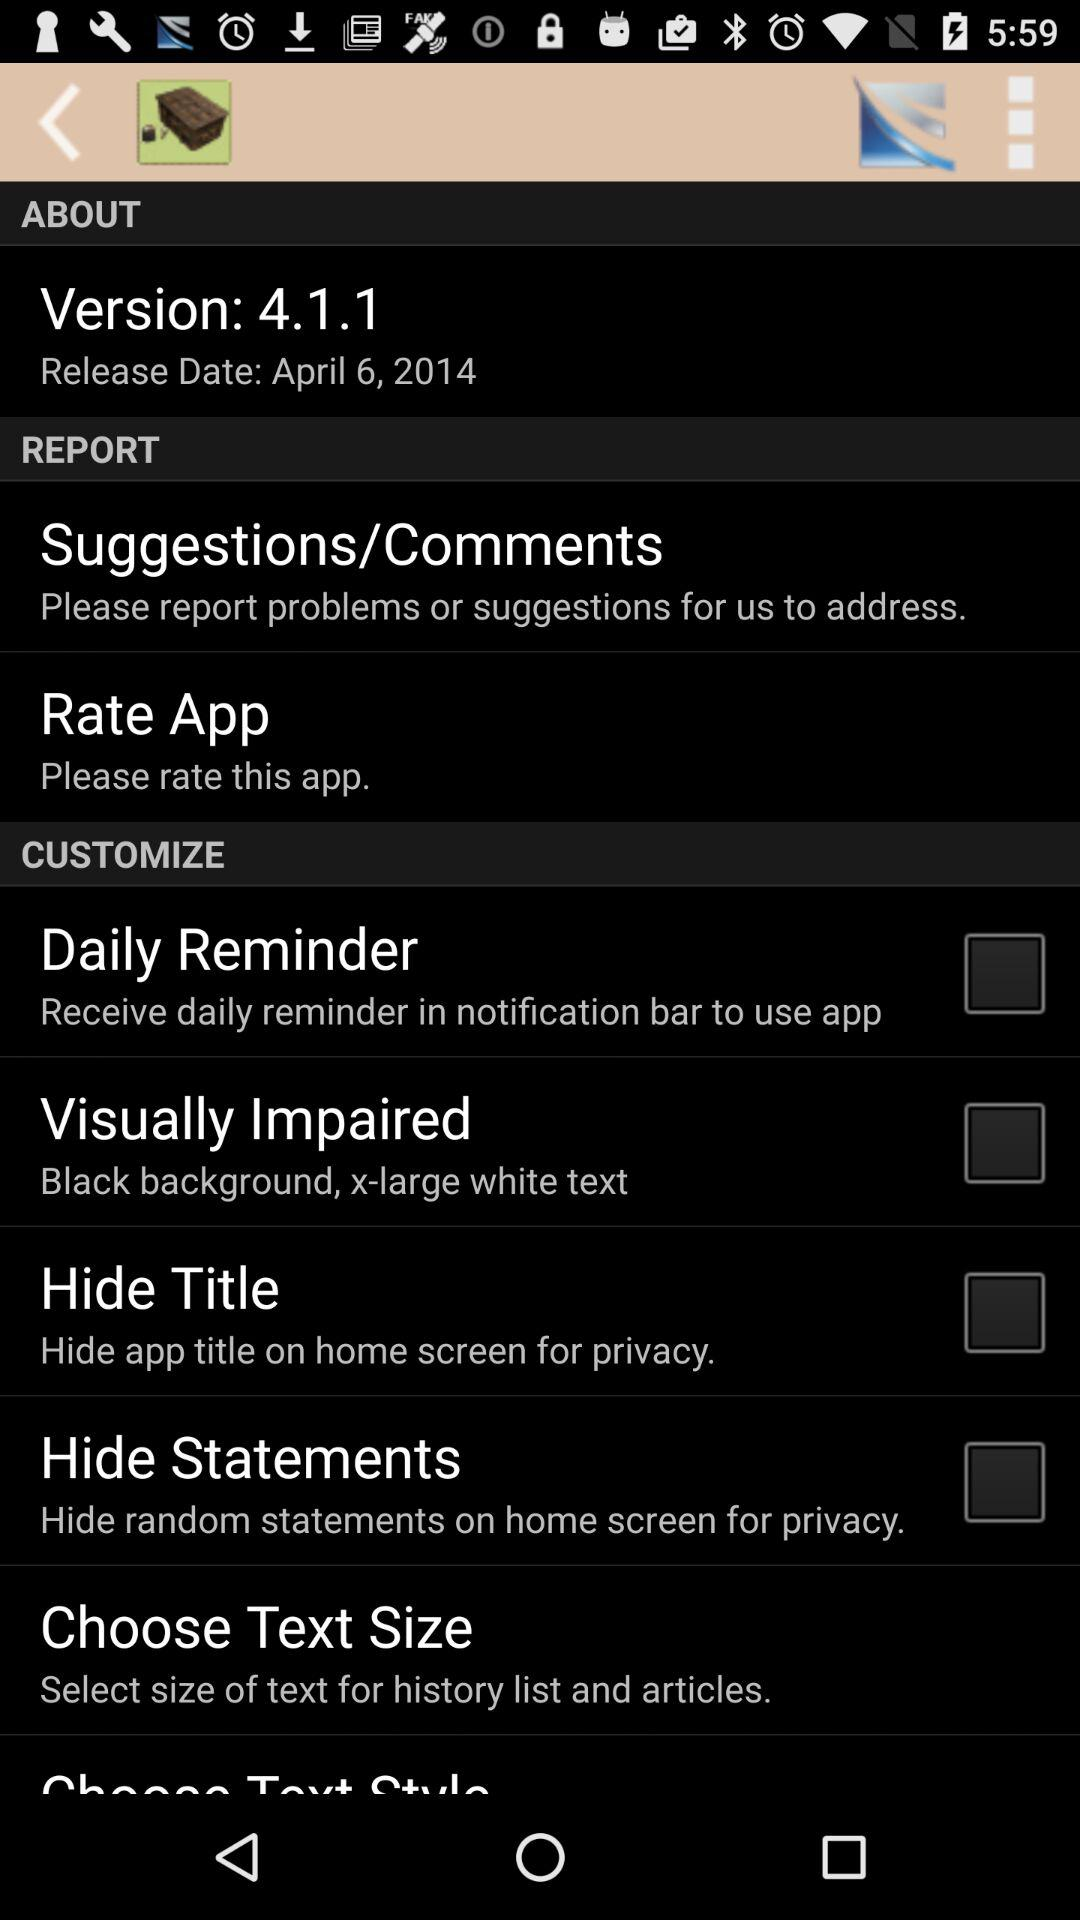Which version is it? The version is 4.1.1. 